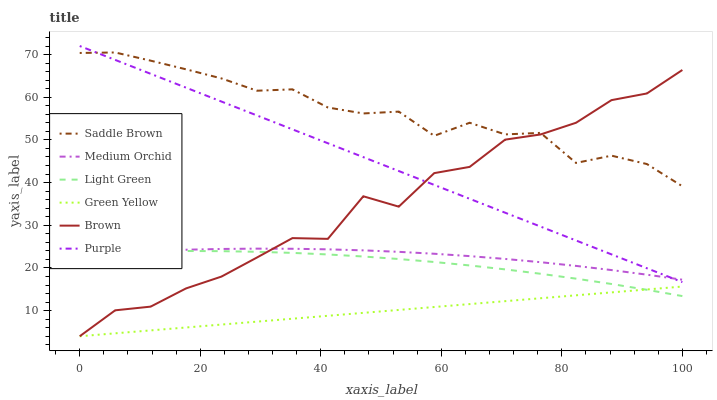Does Purple have the minimum area under the curve?
Answer yes or no. No. Does Purple have the maximum area under the curve?
Answer yes or no. No. Is Purple the smoothest?
Answer yes or no. No. Is Purple the roughest?
Answer yes or no. No. Does Purple have the lowest value?
Answer yes or no. No. Does Medium Orchid have the highest value?
Answer yes or no. No. Is Green Yellow less than Medium Orchid?
Answer yes or no. Yes. Is Purple greater than Light Green?
Answer yes or no. Yes. Does Green Yellow intersect Medium Orchid?
Answer yes or no. No. 